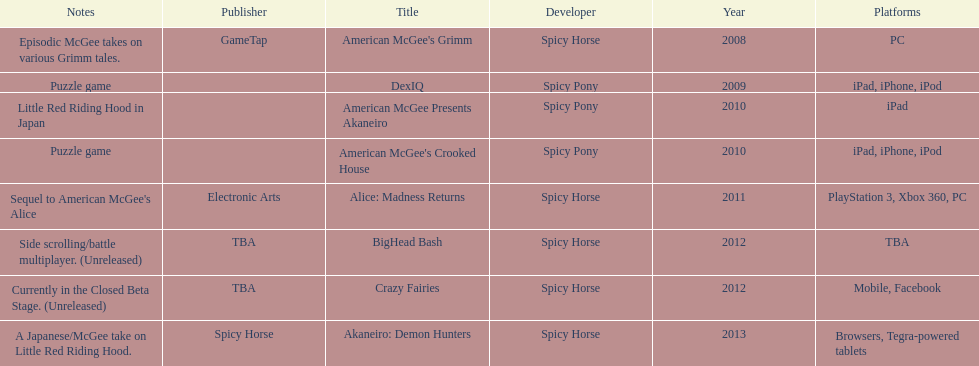Which title is for ipad but not for iphone or ipod? American McGee Presents Akaneiro. 